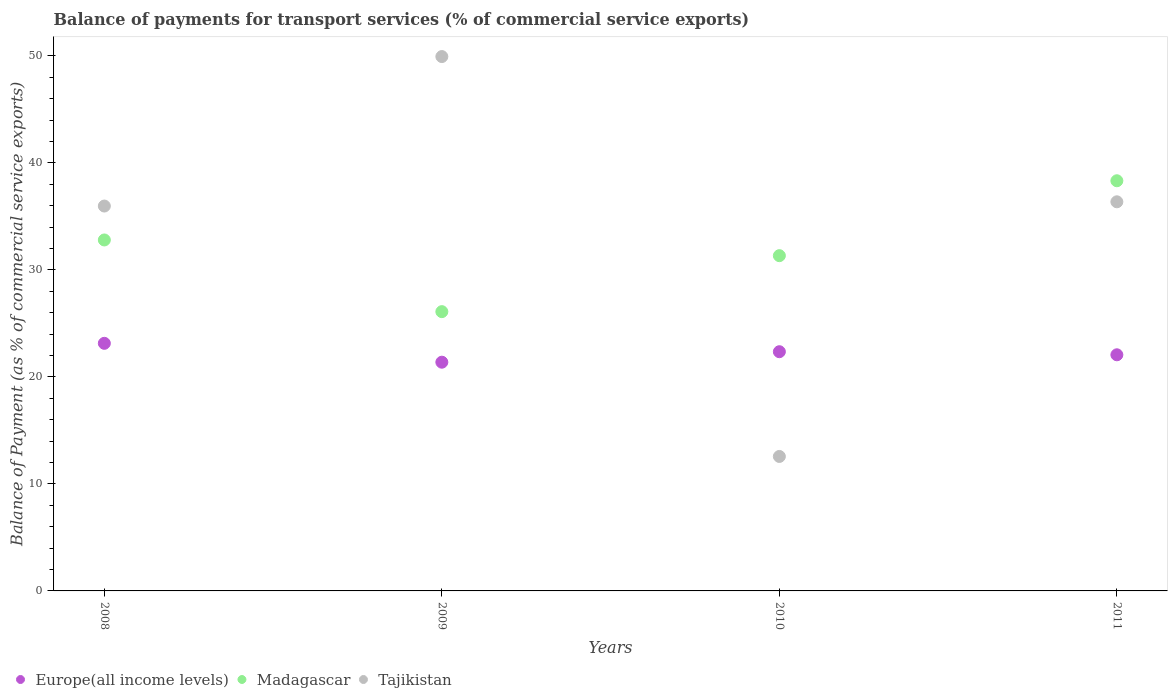Is the number of dotlines equal to the number of legend labels?
Give a very brief answer. Yes. What is the balance of payments for transport services in Tajikistan in 2009?
Your response must be concise. 49.93. Across all years, what is the maximum balance of payments for transport services in Tajikistan?
Keep it short and to the point. 49.93. Across all years, what is the minimum balance of payments for transport services in Europe(all income levels)?
Your response must be concise. 21.37. In which year was the balance of payments for transport services in Tajikistan maximum?
Keep it short and to the point. 2009. In which year was the balance of payments for transport services in Europe(all income levels) minimum?
Provide a succinct answer. 2009. What is the total balance of payments for transport services in Tajikistan in the graph?
Provide a succinct answer. 134.82. What is the difference between the balance of payments for transport services in Europe(all income levels) in 2008 and that in 2011?
Make the answer very short. 1.07. What is the difference between the balance of payments for transport services in Europe(all income levels) in 2008 and the balance of payments for transport services in Madagascar in 2010?
Provide a succinct answer. -8.19. What is the average balance of payments for transport services in Tajikistan per year?
Your answer should be compact. 33.71. In the year 2011, what is the difference between the balance of payments for transport services in Tajikistan and balance of payments for transport services in Europe(all income levels)?
Your response must be concise. 14.3. What is the ratio of the balance of payments for transport services in Europe(all income levels) in 2008 to that in 2011?
Make the answer very short. 1.05. Is the balance of payments for transport services in Europe(all income levels) in 2008 less than that in 2009?
Offer a very short reply. No. What is the difference between the highest and the second highest balance of payments for transport services in Europe(all income levels)?
Make the answer very short. 0.78. What is the difference between the highest and the lowest balance of payments for transport services in Madagascar?
Your response must be concise. 12.23. Is the sum of the balance of payments for transport services in Tajikistan in 2009 and 2011 greater than the maximum balance of payments for transport services in Madagascar across all years?
Keep it short and to the point. Yes. Is it the case that in every year, the sum of the balance of payments for transport services in Europe(all income levels) and balance of payments for transport services in Madagascar  is greater than the balance of payments for transport services in Tajikistan?
Give a very brief answer. No. Is the balance of payments for transport services in Tajikistan strictly greater than the balance of payments for transport services in Madagascar over the years?
Offer a very short reply. No. Is the balance of payments for transport services in Europe(all income levels) strictly less than the balance of payments for transport services in Tajikistan over the years?
Give a very brief answer. No. How many years are there in the graph?
Your answer should be compact. 4. What is the difference between two consecutive major ticks on the Y-axis?
Make the answer very short. 10. Are the values on the major ticks of Y-axis written in scientific E-notation?
Make the answer very short. No. Does the graph contain any zero values?
Your answer should be very brief. No. Does the graph contain grids?
Your answer should be very brief. No. Where does the legend appear in the graph?
Make the answer very short. Bottom left. What is the title of the graph?
Your answer should be compact. Balance of payments for transport services (% of commercial service exports). What is the label or title of the X-axis?
Offer a terse response. Years. What is the label or title of the Y-axis?
Give a very brief answer. Balance of Payment (as % of commercial service exports). What is the Balance of Payment (as % of commercial service exports) in Europe(all income levels) in 2008?
Give a very brief answer. 23.14. What is the Balance of Payment (as % of commercial service exports) in Madagascar in 2008?
Provide a short and direct response. 32.8. What is the Balance of Payment (as % of commercial service exports) of Tajikistan in 2008?
Provide a short and direct response. 35.96. What is the Balance of Payment (as % of commercial service exports) of Europe(all income levels) in 2009?
Your answer should be very brief. 21.37. What is the Balance of Payment (as % of commercial service exports) in Madagascar in 2009?
Give a very brief answer. 26.1. What is the Balance of Payment (as % of commercial service exports) in Tajikistan in 2009?
Offer a very short reply. 49.93. What is the Balance of Payment (as % of commercial service exports) of Europe(all income levels) in 2010?
Your response must be concise. 22.35. What is the Balance of Payment (as % of commercial service exports) of Madagascar in 2010?
Make the answer very short. 31.33. What is the Balance of Payment (as % of commercial service exports) in Tajikistan in 2010?
Keep it short and to the point. 12.57. What is the Balance of Payment (as % of commercial service exports) of Europe(all income levels) in 2011?
Offer a terse response. 22.07. What is the Balance of Payment (as % of commercial service exports) in Madagascar in 2011?
Your answer should be very brief. 38.33. What is the Balance of Payment (as % of commercial service exports) of Tajikistan in 2011?
Make the answer very short. 36.36. Across all years, what is the maximum Balance of Payment (as % of commercial service exports) of Europe(all income levels)?
Provide a short and direct response. 23.14. Across all years, what is the maximum Balance of Payment (as % of commercial service exports) of Madagascar?
Offer a very short reply. 38.33. Across all years, what is the maximum Balance of Payment (as % of commercial service exports) of Tajikistan?
Give a very brief answer. 49.93. Across all years, what is the minimum Balance of Payment (as % of commercial service exports) of Europe(all income levels)?
Ensure brevity in your answer.  21.37. Across all years, what is the minimum Balance of Payment (as % of commercial service exports) in Madagascar?
Make the answer very short. 26.1. Across all years, what is the minimum Balance of Payment (as % of commercial service exports) of Tajikistan?
Your answer should be compact. 12.57. What is the total Balance of Payment (as % of commercial service exports) in Europe(all income levels) in the graph?
Provide a short and direct response. 88.93. What is the total Balance of Payment (as % of commercial service exports) in Madagascar in the graph?
Offer a very short reply. 128.55. What is the total Balance of Payment (as % of commercial service exports) in Tajikistan in the graph?
Your answer should be very brief. 134.82. What is the difference between the Balance of Payment (as % of commercial service exports) in Europe(all income levels) in 2008 and that in 2009?
Provide a short and direct response. 1.76. What is the difference between the Balance of Payment (as % of commercial service exports) in Madagascar in 2008 and that in 2009?
Provide a succinct answer. 6.7. What is the difference between the Balance of Payment (as % of commercial service exports) in Tajikistan in 2008 and that in 2009?
Your response must be concise. -13.97. What is the difference between the Balance of Payment (as % of commercial service exports) of Europe(all income levels) in 2008 and that in 2010?
Keep it short and to the point. 0.78. What is the difference between the Balance of Payment (as % of commercial service exports) of Madagascar in 2008 and that in 2010?
Your response must be concise. 1.47. What is the difference between the Balance of Payment (as % of commercial service exports) of Tajikistan in 2008 and that in 2010?
Provide a succinct answer. 23.4. What is the difference between the Balance of Payment (as % of commercial service exports) in Europe(all income levels) in 2008 and that in 2011?
Offer a terse response. 1.07. What is the difference between the Balance of Payment (as % of commercial service exports) of Madagascar in 2008 and that in 2011?
Provide a succinct answer. -5.53. What is the difference between the Balance of Payment (as % of commercial service exports) of Tajikistan in 2008 and that in 2011?
Ensure brevity in your answer.  -0.4. What is the difference between the Balance of Payment (as % of commercial service exports) of Europe(all income levels) in 2009 and that in 2010?
Ensure brevity in your answer.  -0.98. What is the difference between the Balance of Payment (as % of commercial service exports) in Madagascar in 2009 and that in 2010?
Give a very brief answer. -5.23. What is the difference between the Balance of Payment (as % of commercial service exports) in Tajikistan in 2009 and that in 2010?
Keep it short and to the point. 37.37. What is the difference between the Balance of Payment (as % of commercial service exports) of Europe(all income levels) in 2009 and that in 2011?
Your answer should be compact. -0.69. What is the difference between the Balance of Payment (as % of commercial service exports) of Madagascar in 2009 and that in 2011?
Give a very brief answer. -12.23. What is the difference between the Balance of Payment (as % of commercial service exports) of Tajikistan in 2009 and that in 2011?
Your answer should be compact. 13.57. What is the difference between the Balance of Payment (as % of commercial service exports) in Europe(all income levels) in 2010 and that in 2011?
Give a very brief answer. 0.29. What is the difference between the Balance of Payment (as % of commercial service exports) of Madagascar in 2010 and that in 2011?
Give a very brief answer. -7. What is the difference between the Balance of Payment (as % of commercial service exports) in Tajikistan in 2010 and that in 2011?
Offer a terse response. -23.8. What is the difference between the Balance of Payment (as % of commercial service exports) of Europe(all income levels) in 2008 and the Balance of Payment (as % of commercial service exports) of Madagascar in 2009?
Give a very brief answer. -2.96. What is the difference between the Balance of Payment (as % of commercial service exports) in Europe(all income levels) in 2008 and the Balance of Payment (as % of commercial service exports) in Tajikistan in 2009?
Your answer should be compact. -26.8. What is the difference between the Balance of Payment (as % of commercial service exports) of Madagascar in 2008 and the Balance of Payment (as % of commercial service exports) of Tajikistan in 2009?
Your response must be concise. -17.14. What is the difference between the Balance of Payment (as % of commercial service exports) in Europe(all income levels) in 2008 and the Balance of Payment (as % of commercial service exports) in Madagascar in 2010?
Provide a short and direct response. -8.19. What is the difference between the Balance of Payment (as % of commercial service exports) in Europe(all income levels) in 2008 and the Balance of Payment (as % of commercial service exports) in Tajikistan in 2010?
Your answer should be compact. 10.57. What is the difference between the Balance of Payment (as % of commercial service exports) of Madagascar in 2008 and the Balance of Payment (as % of commercial service exports) of Tajikistan in 2010?
Your answer should be very brief. 20.23. What is the difference between the Balance of Payment (as % of commercial service exports) of Europe(all income levels) in 2008 and the Balance of Payment (as % of commercial service exports) of Madagascar in 2011?
Offer a terse response. -15.19. What is the difference between the Balance of Payment (as % of commercial service exports) of Europe(all income levels) in 2008 and the Balance of Payment (as % of commercial service exports) of Tajikistan in 2011?
Offer a terse response. -13.22. What is the difference between the Balance of Payment (as % of commercial service exports) of Madagascar in 2008 and the Balance of Payment (as % of commercial service exports) of Tajikistan in 2011?
Your answer should be very brief. -3.57. What is the difference between the Balance of Payment (as % of commercial service exports) in Europe(all income levels) in 2009 and the Balance of Payment (as % of commercial service exports) in Madagascar in 2010?
Your answer should be very brief. -9.95. What is the difference between the Balance of Payment (as % of commercial service exports) in Europe(all income levels) in 2009 and the Balance of Payment (as % of commercial service exports) in Tajikistan in 2010?
Your answer should be very brief. 8.81. What is the difference between the Balance of Payment (as % of commercial service exports) of Madagascar in 2009 and the Balance of Payment (as % of commercial service exports) of Tajikistan in 2010?
Provide a short and direct response. 13.53. What is the difference between the Balance of Payment (as % of commercial service exports) in Europe(all income levels) in 2009 and the Balance of Payment (as % of commercial service exports) in Madagascar in 2011?
Your answer should be very brief. -16.95. What is the difference between the Balance of Payment (as % of commercial service exports) of Europe(all income levels) in 2009 and the Balance of Payment (as % of commercial service exports) of Tajikistan in 2011?
Give a very brief answer. -14.99. What is the difference between the Balance of Payment (as % of commercial service exports) of Madagascar in 2009 and the Balance of Payment (as % of commercial service exports) of Tajikistan in 2011?
Provide a succinct answer. -10.27. What is the difference between the Balance of Payment (as % of commercial service exports) of Europe(all income levels) in 2010 and the Balance of Payment (as % of commercial service exports) of Madagascar in 2011?
Your answer should be compact. -15.97. What is the difference between the Balance of Payment (as % of commercial service exports) of Europe(all income levels) in 2010 and the Balance of Payment (as % of commercial service exports) of Tajikistan in 2011?
Ensure brevity in your answer.  -14.01. What is the difference between the Balance of Payment (as % of commercial service exports) of Madagascar in 2010 and the Balance of Payment (as % of commercial service exports) of Tajikistan in 2011?
Give a very brief answer. -5.03. What is the average Balance of Payment (as % of commercial service exports) of Europe(all income levels) per year?
Ensure brevity in your answer.  22.23. What is the average Balance of Payment (as % of commercial service exports) in Madagascar per year?
Your answer should be compact. 32.14. What is the average Balance of Payment (as % of commercial service exports) in Tajikistan per year?
Offer a very short reply. 33.71. In the year 2008, what is the difference between the Balance of Payment (as % of commercial service exports) in Europe(all income levels) and Balance of Payment (as % of commercial service exports) in Madagascar?
Your response must be concise. -9.66. In the year 2008, what is the difference between the Balance of Payment (as % of commercial service exports) of Europe(all income levels) and Balance of Payment (as % of commercial service exports) of Tajikistan?
Ensure brevity in your answer.  -12.83. In the year 2008, what is the difference between the Balance of Payment (as % of commercial service exports) of Madagascar and Balance of Payment (as % of commercial service exports) of Tajikistan?
Your answer should be very brief. -3.17. In the year 2009, what is the difference between the Balance of Payment (as % of commercial service exports) in Europe(all income levels) and Balance of Payment (as % of commercial service exports) in Madagascar?
Ensure brevity in your answer.  -4.72. In the year 2009, what is the difference between the Balance of Payment (as % of commercial service exports) of Europe(all income levels) and Balance of Payment (as % of commercial service exports) of Tajikistan?
Provide a short and direct response. -28.56. In the year 2009, what is the difference between the Balance of Payment (as % of commercial service exports) in Madagascar and Balance of Payment (as % of commercial service exports) in Tajikistan?
Your answer should be very brief. -23.84. In the year 2010, what is the difference between the Balance of Payment (as % of commercial service exports) in Europe(all income levels) and Balance of Payment (as % of commercial service exports) in Madagascar?
Provide a succinct answer. -8.97. In the year 2010, what is the difference between the Balance of Payment (as % of commercial service exports) in Europe(all income levels) and Balance of Payment (as % of commercial service exports) in Tajikistan?
Your answer should be compact. 9.79. In the year 2010, what is the difference between the Balance of Payment (as % of commercial service exports) of Madagascar and Balance of Payment (as % of commercial service exports) of Tajikistan?
Ensure brevity in your answer.  18.76. In the year 2011, what is the difference between the Balance of Payment (as % of commercial service exports) in Europe(all income levels) and Balance of Payment (as % of commercial service exports) in Madagascar?
Provide a succinct answer. -16.26. In the year 2011, what is the difference between the Balance of Payment (as % of commercial service exports) of Europe(all income levels) and Balance of Payment (as % of commercial service exports) of Tajikistan?
Your answer should be compact. -14.3. In the year 2011, what is the difference between the Balance of Payment (as % of commercial service exports) in Madagascar and Balance of Payment (as % of commercial service exports) in Tajikistan?
Provide a short and direct response. 1.97. What is the ratio of the Balance of Payment (as % of commercial service exports) of Europe(all income levels) in 2008 to that in 2009?
Your answer should be very brief. 1.08. What is the ratio of the Balance of Payment (as % of commercial service exports) of Madagascar in 2008 to that in 2009?
Give a very brief answer. 1.26. What is the ratio of the Balance of Payment (as % of commercial service exports) of Tajikistan in 2008 to that in 2009?
Your response must be concise. 0.72. What is the ratio of the Balance of Payment (as % of commercial service exports) in Europe(all income levels) in 2008 to that in 2010?
Provide a short and direct response. 1.04. What is the ratio of the Balance of Payment (as % of commercial service exports) in Madagascar in 2008 to that in 2010?
Offer a very short reply. 1.05. What is the ratio of the Balance of Payment (as % of commercial service exports) in Tajikistan in 2008 to that in 2010?
Ensure brevity in your answer.  2.86. What is the ratio of the Balance of Payment (as % of commercial service exports) of Europe(all income levels) in 2008 to that in 2011?
Provide a succinct answer. 1.05. What is the ratio of the Balance of Payment (as % of commercial service exports) of Madagascar in 2008 to that in 2011?
Your answer should be very brief. 0.86. What is the ratio of the Balance of Payment (as % of commercial service exports) in Europe(all income levels) in 2009 to that in 2010?
Provide a succinct answer. 0.96. What is the ratio of the Balance of Payment (as % of commercial service exports) in Madagascar in 2009 to that in 2010?
Offer a very short reply. 0.83. What is the ratio of the Balance of Payment (as % of commercial service exports) in Tajikistan in 2009 to that in 2010?
Keep it short and to the point. 3.97. What is the ratio of the Balance of Payment (as % of commercial service exports) of Europe(all income levels) in 2009 to that in 2011?
Your answer should be compact. 0.97. What is the ratio of the Balance of Payment (as % of commercial service exports) of Madagascar in 2009 to that in 2011?
Make the answer very short. 0.68. What is the ratio of the Balance of Payment (as % of commercial service exports) of Tajikistan in 2009 to that in 2011?
Your response must be concise. 1.37. What is the ratio of the Balance of Payment (as % of commercial service exports) of Europe(all income levels) in 2010 to that in 2011?
Your response must be concise. 1.01. What is the ratio of the Balance of Payment (as % of commercial service exports) in Madagascar in 2010 to that in 2011?
Provide a succinct answer. 0.82. What is the ratio of the Balance of Payment (as % of commercial service exports) in Tajikistan in 2010 to that in 2011?
Make the answer very short. 0.35. What is the difference between the highest and the second highest Balance of Payment (as % of commercial service exports) in Europe(all income levels)?
Provide a short and direct response. 0.78. What is the difference between the highest and the second highest Balance of Payment (as % of commercial service exports) of Madagascar?
Keep it short and to the point. 5.53. What is the difference between the highest and the second highest Balance of Payment (as % of commercial service exports) in Tajikistan?
Your answer should be compact. 13.57. What is the difference between the highest and the lowest Balance of Payment (as % of commercial service exports) in Europe(all income levels)?
Offer a terse response. 1.76. What is the difference between the highest and the lowest Balance of Payment (as % of commercial service exports) of Madagascar?
Offer a very short reply. 12.23. What is the difference between the highest and the lowest Balance of Payment (as % of commercial service exports) in Tajikistan?
Keep it short and to the point. 37.37. 